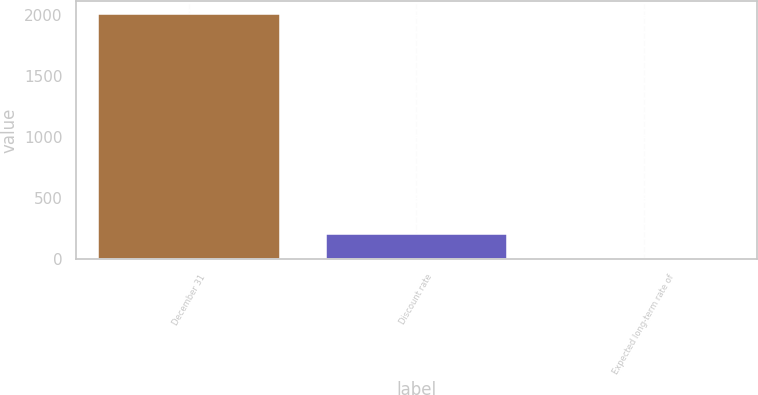Convert chart to OTSL. <chart><loc_0><loc_0><loc_500><loc_500><bar_chart><fcel>December 31<fcel>Discount rate<fcel>Expected long-term rate of<nl><fcel>2009<fcel>205.18<fcel>4.75<nl></chart> 